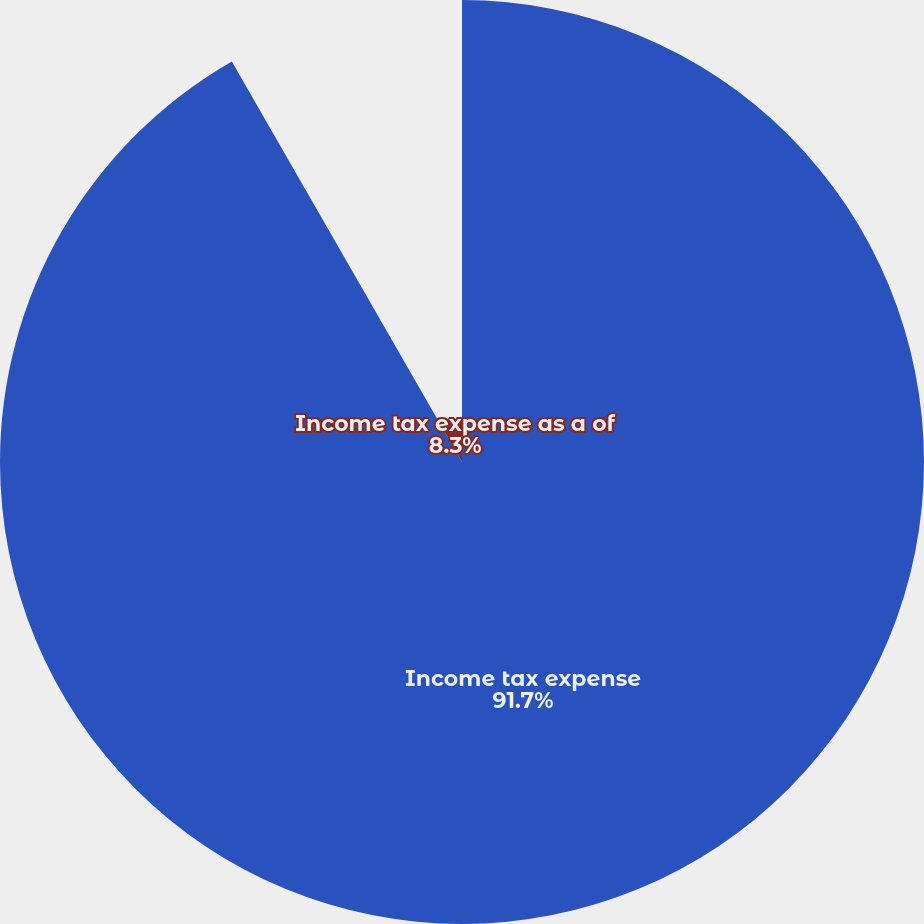Convert chart to OTSL. <chart><loc_0><loc_0><loc_500><loc_500><pie_chart><fcel>Income tax expense<fcel>Income tax expense as a of<nl><fcel>91.7%<fcel>8.3%<nl></chart> 